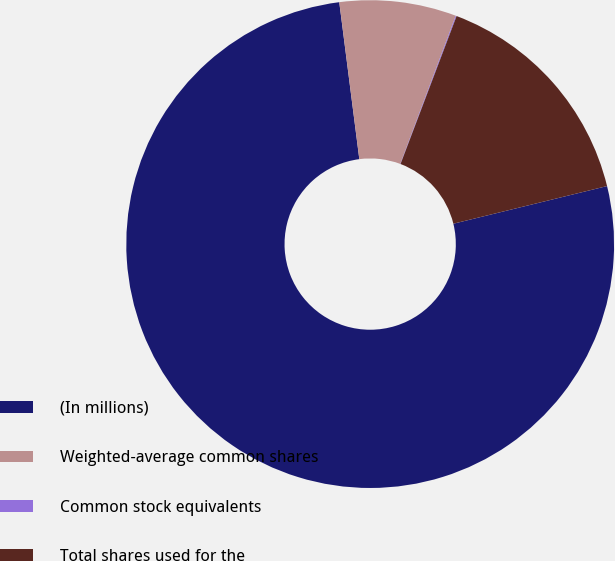Convert chart. <chart><loc_0><loc_0><loc_500><loc_500><pie_chart><fcel>(In millions)<fcel>Weighted-average common shares<fcel>Common stock equivalents<fcel>Total shares used for the<nl><fcel>76.8%<fcel>7.73%<fcel>0.06%<fcel>15.41%<nl></chart> 